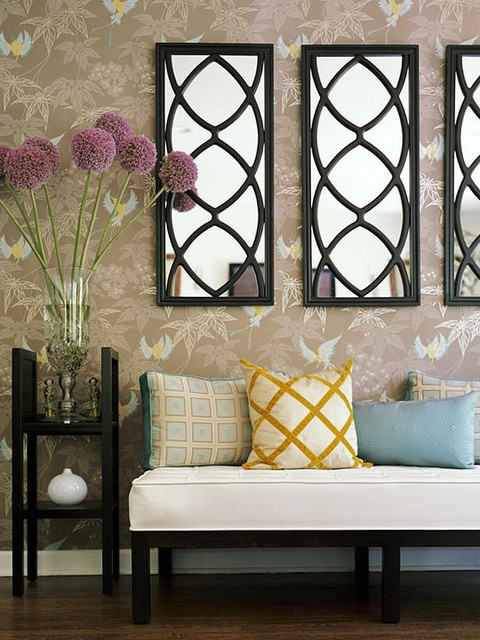Describe the objects in this image and their specific colors. I can see bench in gray, lightgray, and black tones, couch in gray, lightgray, black, and darkgray tones, and vase in gray, olive, darkgreen, and black tones in this image. 